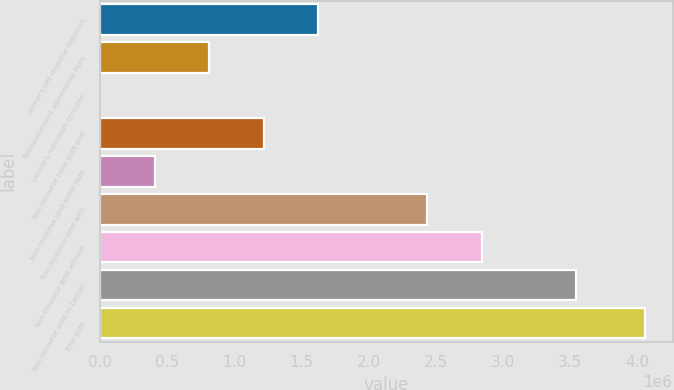<chart> <loc_0><loc_0><loc_500><loc_500><bar_chart><fcel>Lennar's net recourse exposure<fcel>Reimbursement agreements from<fcel>Lennar's maximum recourse<fcel>Non-recourse bank debt and<fcel>Non-recourse land seller debt<fcel>Non-recourse debt with<fcel>Non-recourse debt without<fcel>Non-recourse debt to Lennar<fcel>Total debt<nl><fcel>1.62483e+06<fcel>812422<fcel>13<fcel>1.21863e+06<fcel>406218<fcel>2.43724e+06<fcel>2.84344e+06<fcel>3.54218e+06<fcel>4.06206e+06<nl></chart> 